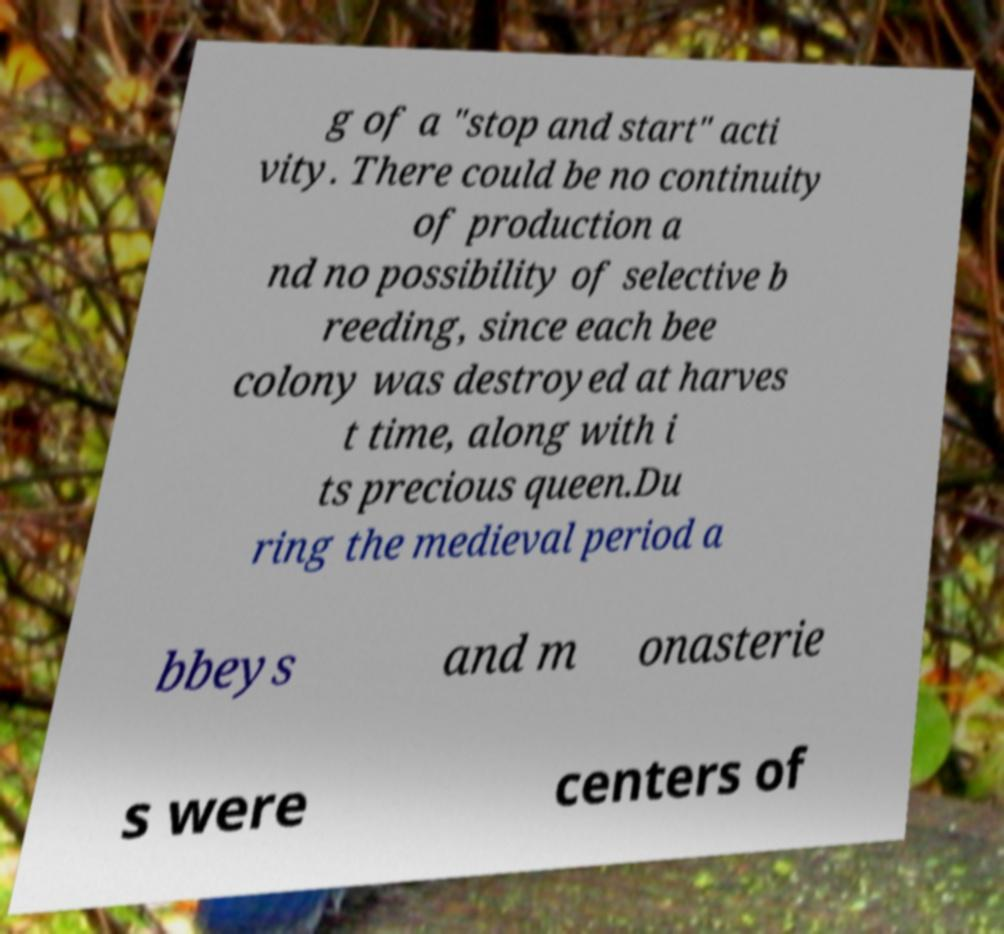What messages or text are displayed in this image? I need them in a readable, typed format. g of a "stop and start" acti vity. There could be no continuity of production a nd no possibility of selective b reeding, since each bee colony was destroyed at harves t time, along with i ts precious queen.Du ring the medieval period a bbeys and m onasterie s were centers of 